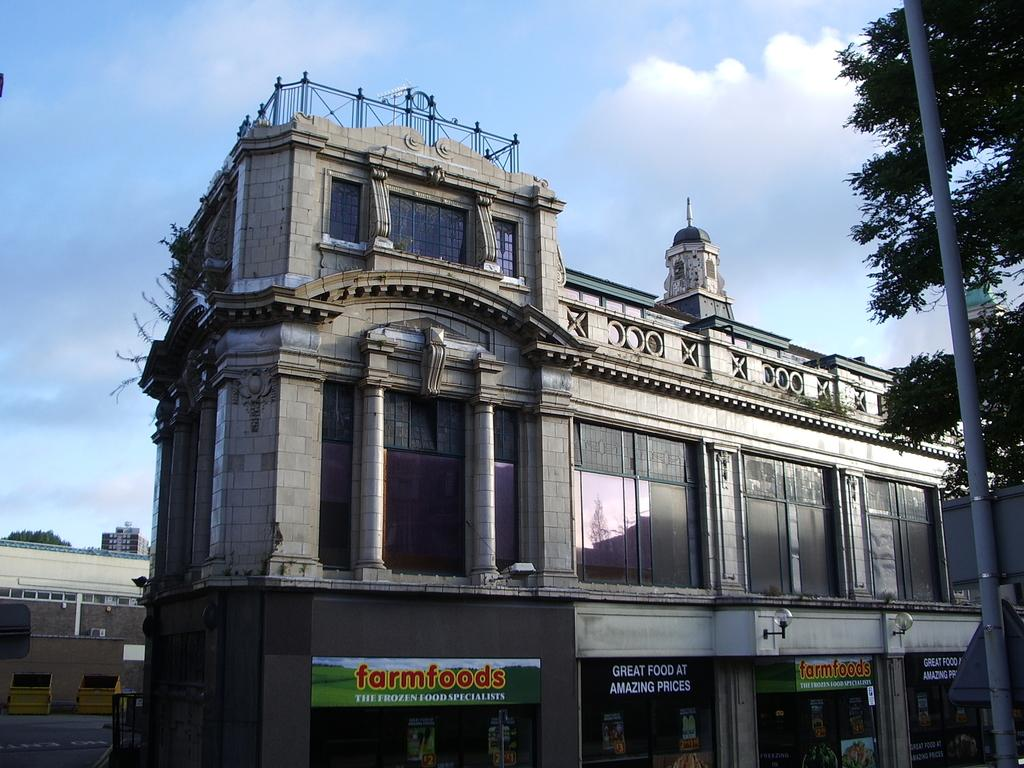<image>
Give a short and clear explanation of the subsequent image. Farmfoods provides great food at amazing prices to consumers. 